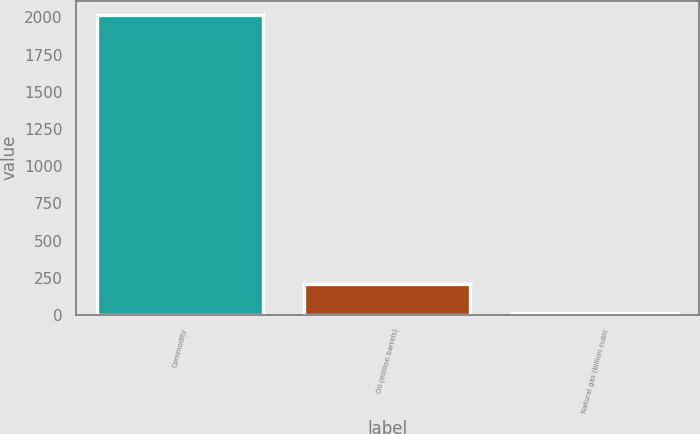Convert chart to OTSL. <chart><loc_0><loc_0><loc_500><loc_500><bar_chart><fcel>Commodity<fcel>Oil (million barrels)<fcel>Natural gas (billion cubic<nl><fcel>2013<fcel>210.3<fcel>10<nl></chart> 